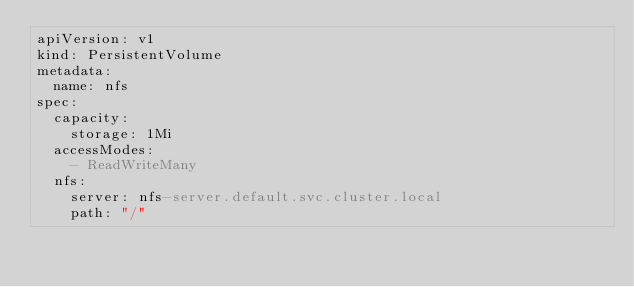Convert code to text. <code><loc_0><loc_0><loc_500><loc_500><_YAML_>apiVersion: v1
kind: PersistentVolume
metadata:
  name: nfs
spec:
  capacity:
    storage: 1Mi
  accessModes:
    - ReadWriteMany
  nfs:
    server: nfs-server.default.svc.cluster.local
    path: "/"
</code> 